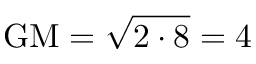<formula> <loc_0><loc_0><loc_500><loc_500>{ G M } = { \sqrt { 2 \cdot 8 } } = 4</formula> 